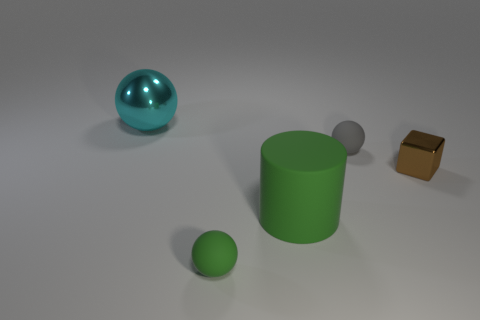Subtract all big spheres. How many spheres are left? 2 Add 4 brown metallic cubes. How many objects exist? 9 Subtract all cylinders. How many objects are left? 4 Add 3 tiny matte objects. How many tiny matte objects are left? 5 Add 3 metallic objects. How many metallic objects exist? 5 Subtract 1 brown cubes. How many objects are left? 4 Subtract all big yellow metal cylinders. Subtract all cyan metallic objects. How many objects are left? 4 